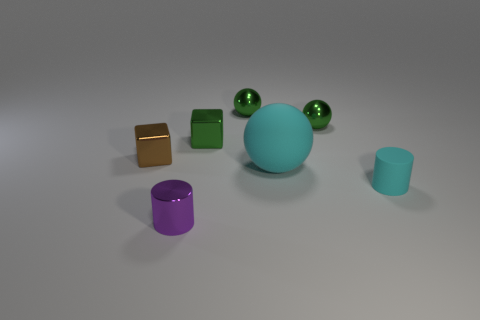What number of balls are either large things or matte objects?
Your answer should be compact. 1. Are there any other things of the same color as the big rubber thing?
Provide a succinct answer. Yes. What is the tiny cube that is left of the metal object that is in front of the tiny cyan cylinder made of?
Provide a short and direct response. Metal. Is the cyan ball made of the same material as the small ball that is left of the cyan sphere?
Provide a short and direct response. No. How many things are either tiny green objects right of the rubber sphere or small green metal objects?
Your answer should be compact. 3. Are there any small things of the same color as the large rubber object?
Make the answer very short. Yes. There is a small purple metal object; is it the same shape as the matte object that is to the right of the large object?
Your answer should be compact. Yes. How many objects are both to the left of the large cyan object and behind the brown metallic thing?
Offer a terse response. 2. There is another tiny object that is the same shape as the tiny purple object; what is its material?
Provide a succinct answer. Rubber. There is a ball in front of the metal cube that is to the right of the metal cylinder; what size is it?
Make the answer very short. Large. 